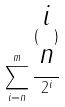Convert formula to latex. <formula><loc_0><loc_0><loc_500><loc_500>\sum _ { i = n } ^ { m } \frac { ( \begin{matrix} i \\ n \end{matrix} ) } { 2 ^ { i } }</formula> 